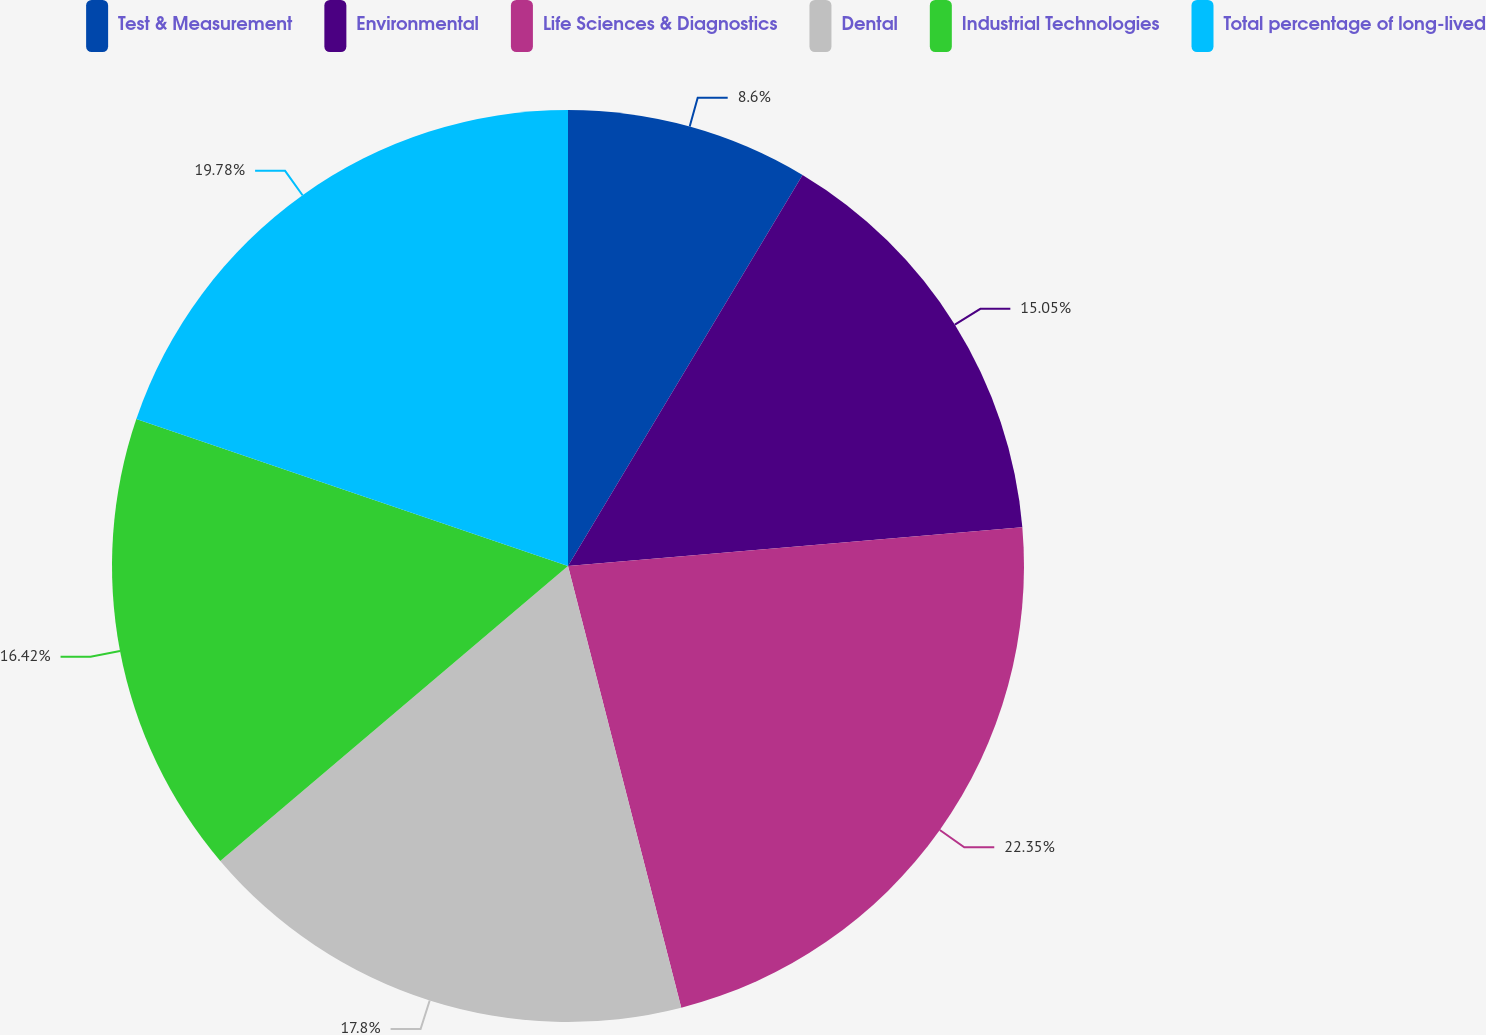Convert chart. <chart><loc_0><loc_0><loc_500><loc_500><pie_chart><fcel>Test & Measurement<fcel>Environmental<fcel>Life Sciences & Diagnostics<fcel>Dental<fcel>Industrial Technologies<fcel>Total percentage of long-lived<nl><fcel>8.6%<fcel>15.05%<fcel>22.36%<fcel>17.8%<fcel>16.42%<fcel>19.78%<nl></chart> 